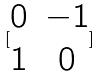Convert formula to latex. <formula><loc_0><loc_0><loc_500><loc_500>[ \begin{matrix} 0 & - 1 \\ 1 & 0 \end{matrix} ]</formula> 